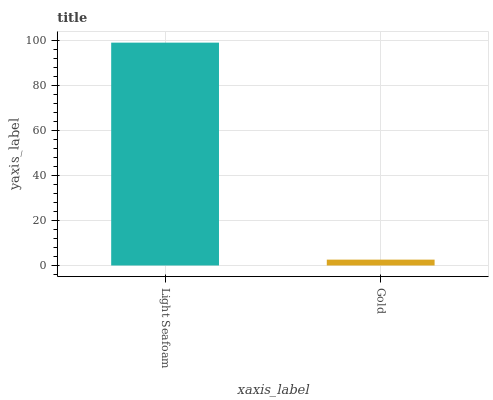Is Gold the minimum?
Answer yes or no. Yes. Is Light Seafoam the maximum?
Answer yes or no. Yes. Is Gold the maximum?
Answer yes or no. No. Is Light Seafoam greater than Gold?
Answer yes or no. Yes. Is Gold less than Light Seafoam?
Answer yes or no. Yes. Is Gold greater than Light Seafoam?
Answer yes or no. No. Is Light Seafoam less than Gold?
Answer yes or no. No. Is Light Seafoam the high median?
Answer yes or no. Yes. Is Gold the low median?
Answer yes or no. Yes. Is Gold the high median?
Answer yes or no. No. Is Light Seafoam the low median?
Answer yes or no. No. 